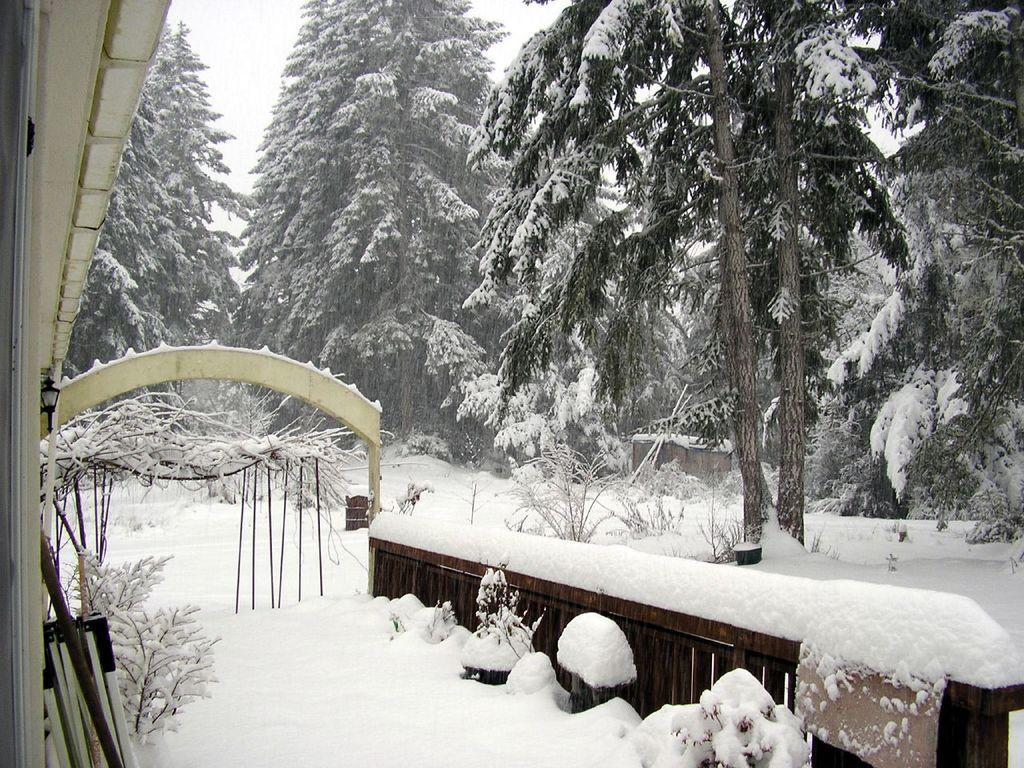Describe this image in one or two sentences. We can see plants,wooden object,snow,roof top and arch. In the background we can see trees and sky. 